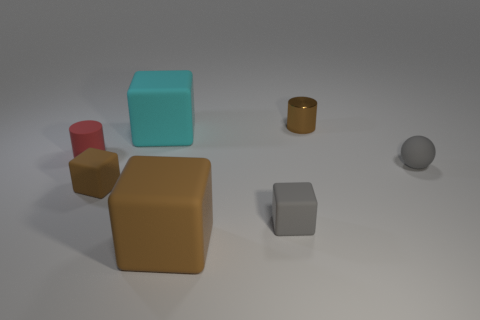Add 3 tiny brown cubes. How many objects exist? 10 Subtract all large brown matte cubes. How many cubes are left? 3 Subtract all cyan blocks. How many blocks are left? 3 Add 3 small gray balls. How many small gray balls are left? 4 Add 7 tiny red matte objects. How many tiny red matte objects exist? 8 Subtract 1 brown blocks. How many objects are left? 6 Subtract all cylinders. How many objects are left? 5 Subtract 1 cylinders. How many cylinders are left? 1 Subtract all purple cylinders. Subtract all yellow balls. How many cylinders are left? 2 Subtract all brown cubes. How many yellow cylinders are left? 0 